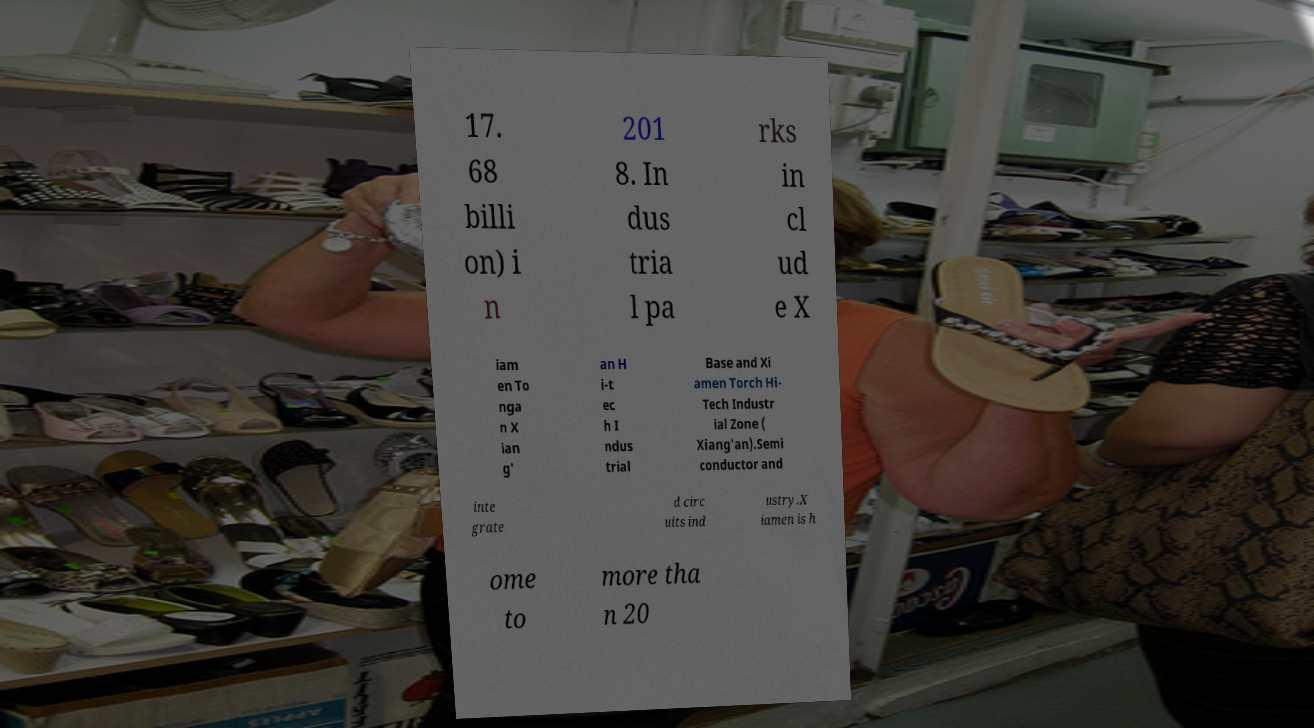There's text embedded in this image that I need extracted. Can you transcribe it verbatim? 17. 68 billi on) i n 201 8. In dus tria l pa rks in cl ud e X iam en To nga n X ian g' an H i-t ec h I ndus trial Base and Xi amen Torch Hi- Tech Industr ial Zone ( Xiang'an).Semi conductor and inte grate d circ uits ind ustry.X iamen is h ome to more tha n 20 